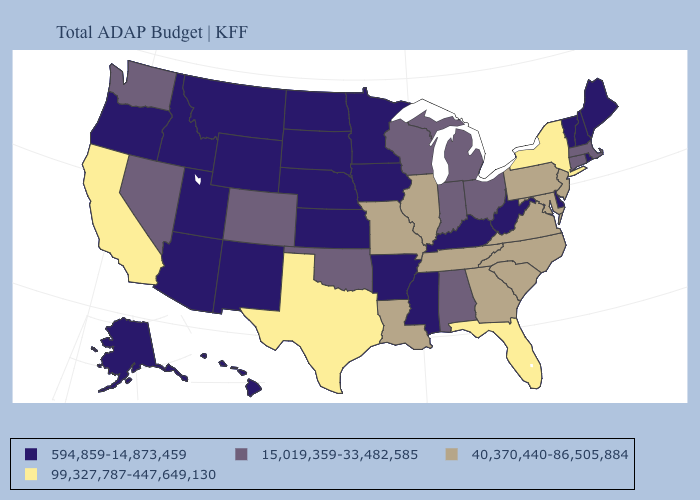What is the value of Nevada?
Quick response, please. 15,019,359-33,482,585. What is the value of South Dakota?
Quick response, please. 594,859-14,873,459. What is the value of Oklahoma?
Be succinct. 15,019,359-33,482,585. Name the states that have a value in the range 99,327,787-447,649,130?
Keep it brief. California, Florida, New York, Texas. Among the states that border Iowa , does Illinois have the highest value?
Quick response, please. Yes. What is the lowest value in states that border Kentucky?
Short answer required. 594,859-14,873,459. Name the states that have a value in the range 594,859-14,873,459?
Short answer required. Alaska, Arizona, Arkansas, Delaware, Hawaii, Idaho, Iowa, Kansas, Kentucky, Maine, Minnesota, Mississippi, Montana, Nebraska, New Hampshire, New Mexico, North Dakota, Oregon, Rhode Island, South Dakota, Utah, Vermont, West Virginia, Wyoming. Does Missouri have a lower value than Texas?
Concise answer only. Yes. Among the states that border West Virginia , which have the highest value?
Write a very short answer. Maryland, Pennsylvania, Virginia. What is the value of Iowa?
Concise answer only. 594,859-14,873,459. Which states have the lowest value in the USA?
Short answer required. Alaska, Arizona, Arkansas, Delaware, Hawaii, Idaho, Iowa, Kansas, Kentucky, Maine, Minnesota, Mississippi, Montana, Nebraska, New Hampshire, New Mexico, North Dakota, Oregon, Rhode Island, South Dakota, Utah, Vermont, West Virginia, Wyoming. Among the states that border Missouri , which have the highest value?
Short answer required. Illinois, Tennessee. What is the lowest value in the USA?
Be succinct. 594,859-14,873,459. Does Texas have the highest value in the USA?
Short answer required. Yes. What is the value of Florida?
Give a very brief answer. 99,327,787-447,649,130. 